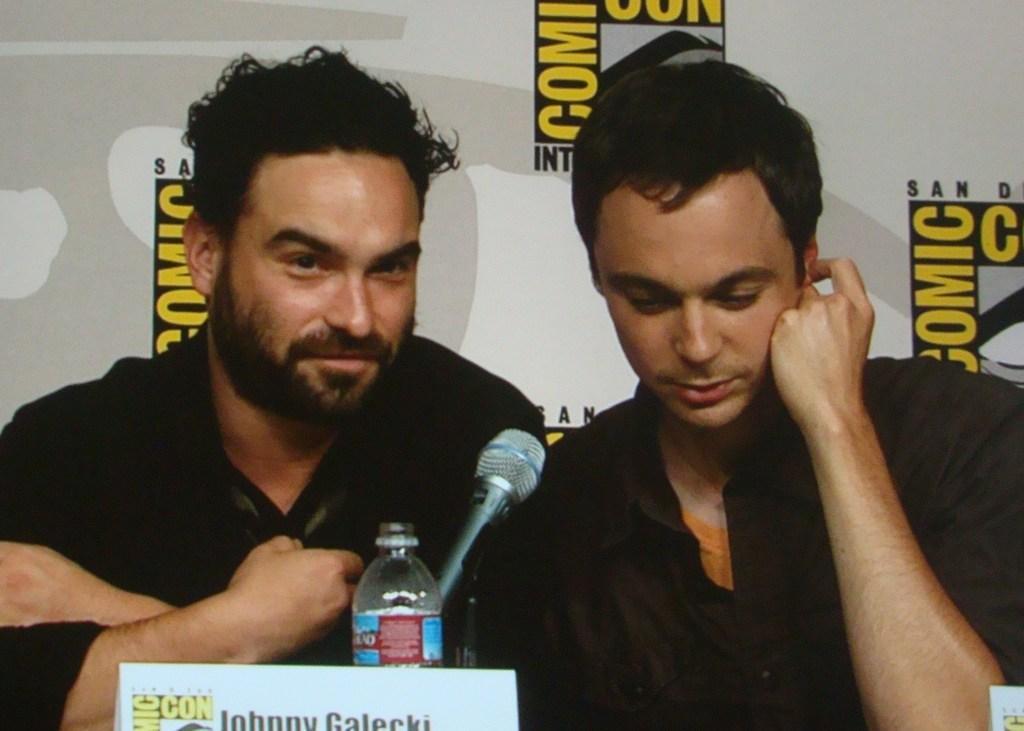Could you give a brief overview of what you see in this image? In this picture we can see two men, they are seated, in front of them we can find a microphone, bottle and a name board, in the background we can see a hoarding. 